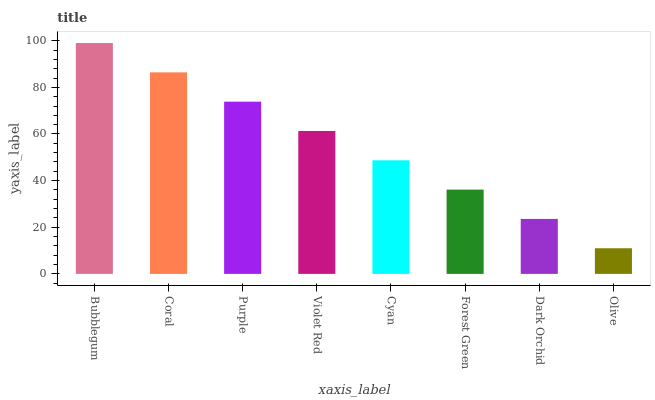Is Olive the minimum?
Answer yes or no. Yes. Is Bubblegum the maximum?
Answer yes or no. Yes. Is Coral the minimum?
Answer yes or no. No. Is Coral the maximum?
Answer yes or no. No. Is Bubblegum greater than Coral?
Answer yes or no. Yes. Is Coral less than Bubblegum?
Answer yes or no. Yes. Is Coral greater than Bubblegum?
Answer yes or no. No. Is Bubblegum less than Coral?
Answer yes or no. No. Is Violet Red the high median?
Answer yes or no. Yes. Is Cyan the low median?
Answer yes or no. Yes. Is Coral the high median?
Answer yes or no. No. Is Violet Red the low median?
Answer yes or no. No. 